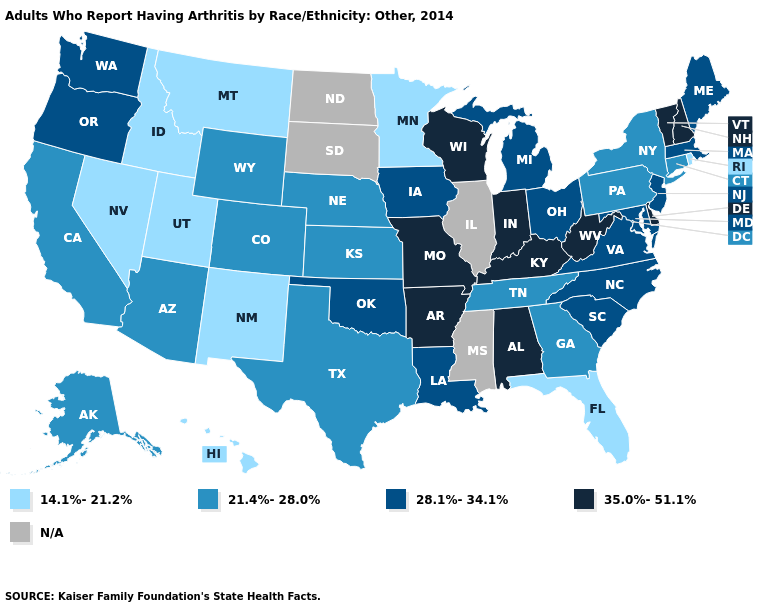Does Alaska have the lowest value in the USA?
Concise answer only. No. What is the value of Pennsylvania?
Keep it brief. 21.4%-28.0%. How many symbols are there in the legend?
Answer briefly. 5. What is the value of Montana?
Give a very brief answer. 14.1%-21.2%. Does Maine have the lowest value in the USA?
Quick response, please. No. What is the highest value in the USA?
Concise answer only. 35.0%-51.1%. Which states have the lowest value in the USA?
Short answer required. Florida, Hawaii, Idaho, Minnesota, Montana, Nevada, New Mexico, Rhode Island, Utah. Which states have the highest value in the USA?
Quick response, please. Alabama, Arkansas, Delaware, Indiana, Kentucky, Missouri, New Hampshire, Vermont, West Virginia, Wisconsin. Which states hav the highest value in the South?
Quick response, please. Alabama, Arkansas, Delaware, Kentucky, West Virginia. What is the value of Missouri?
Write a very short answer. 35.0%-51.1%. What is the value of Tennessee?
Keep it brief. 21.4%-28.0%. Name the states that have a value in the range 35.0%-51.1%?
Be succinct. Alabama, Arkansas, Delaware, Indiana, Kentucky, Missouri, New Hampshire, Vermont, West Virginia, Wisconsin. What is the highest value in the USA?
Give a very brief answer. 35.0%-51.1%. Name the states that have a value in the range 35.0%-51.1%?
Give a very brief answer. Alabama, Arkansas, Delaware, Indiana, Kentucky, Missouri, New Hampshire, Vermont, West Virginia, Wisconsin. How many symbols are there in the legend?
Quick response, please. 5. 